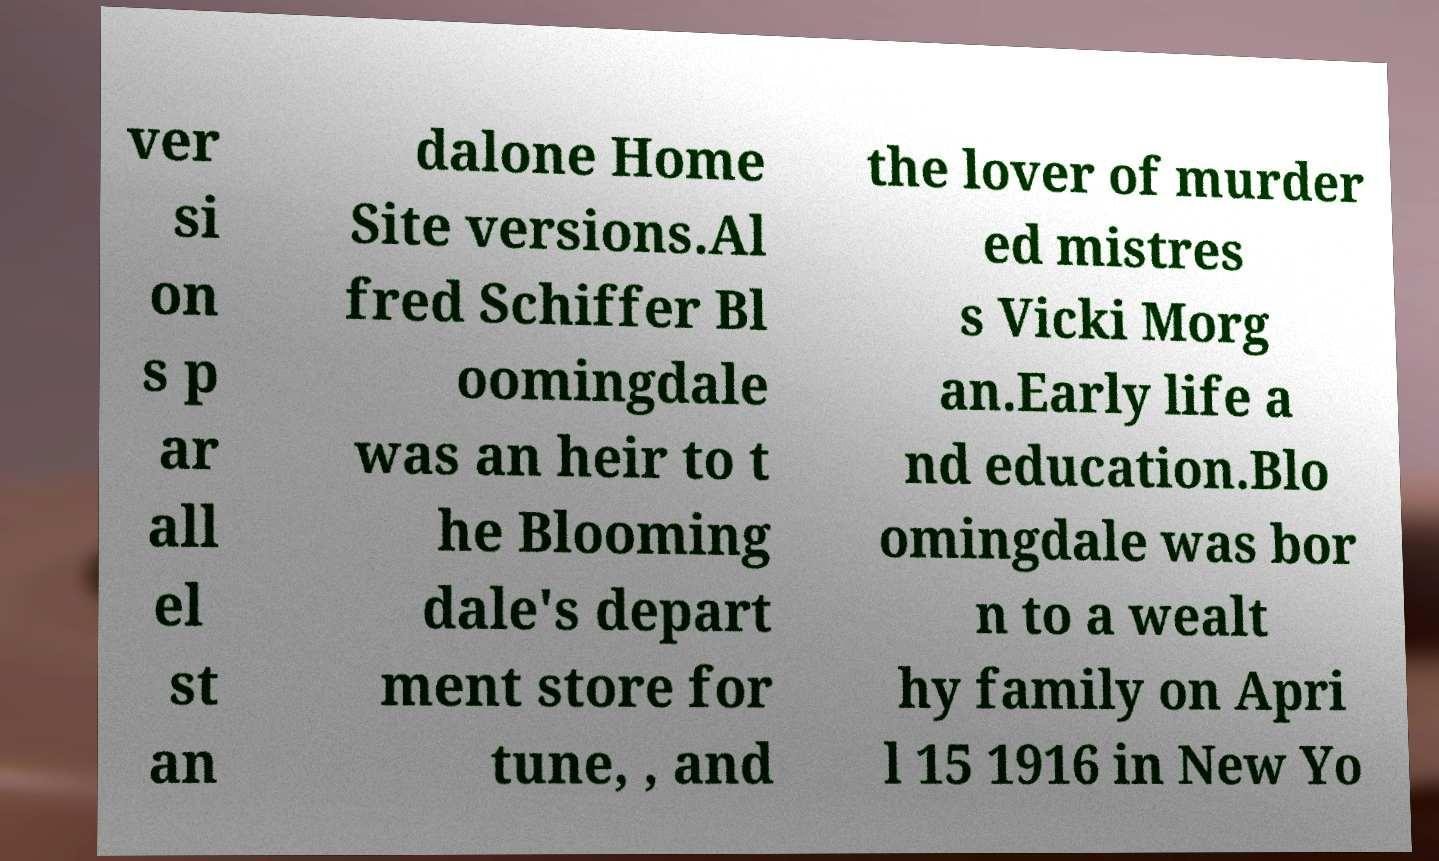What messages or text are displayed in this image? I need them in a readable, typed format. ver si on s p ar all el st an dalone Home Site versions.Al fred Schiffer Bl oomingdale was an heir to t he Blooming dale's depart ment store for tune, , and the lover of murder ed mistres s Vicki Morg an.Early life a nd education.Blo omingdale was bor n to a wealt hy family on Apri l 15 1916 in New Yo 